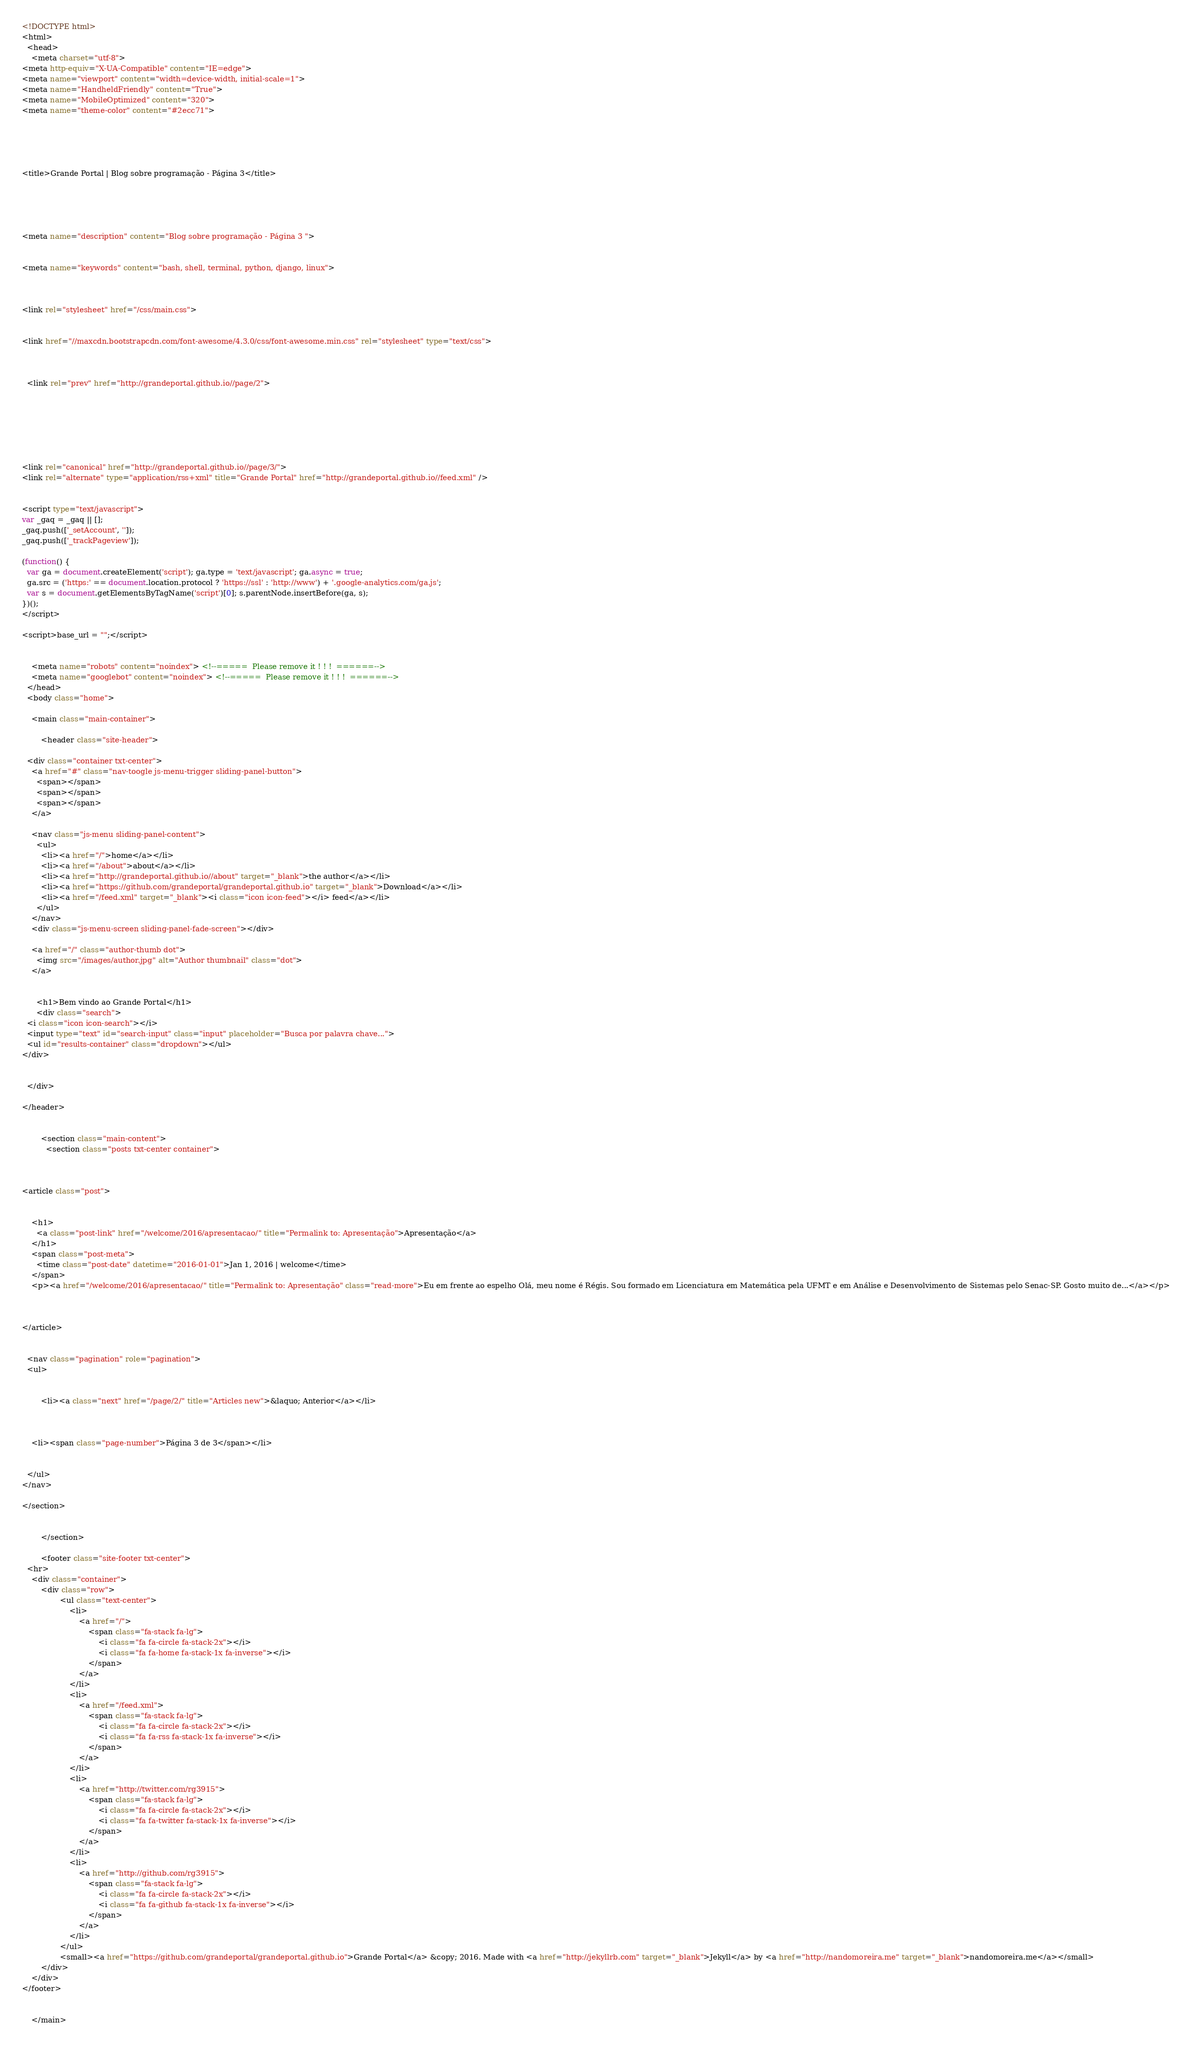Convert code to text. <code><loc_0><loc_0><loc_500><loc_500><_HTML_><!DOCTYPE html>
<html>
  <head>
    <meta charset="utf-8">
<meta http-equiv="X-UA-Compatible" content="IE=edge">
<meta name="viewport" content="width=device-width, initial-scale=1">
<meta name="HandheldFriendly" content="True">
<meta name="MobileOptimized" content="320">
<meta name="theme-color" content="#2ecc71">





<title>Grande Portal | Blog sobre programação - Página 3</title>





<meta name="description" content="Blog sobre programação - Página 3 ">


<meta name="keywords" content="bash, shell, terminal, python, django, linux">



<link rel="stylesheet" href="/css/main.css">


<link href="//maxcdn.bootstrapcdn.com/font-awesome/4.3.0/css/font-awesome.min.css" rel="stylesheet" type="text/css">



  <link rel="prev" href="http://grandeportal.github.io//page/2">







<link rel="canonical" href="http://grandeportal.github.io//page/3/">
<link rel="alternate" type="application/rss+xml" title="Grande Portal" href="http://grandeportal.github.io//feed.xml" />


<script type="text/javascript">
var _gaq = _gaq || [];
_gaq.push(['_setAccount', '']);
_gaq.push(['_trackPageview']);

(function() {
  var ga = document.createElement('script'); ga.type = 'text/javascript'; ga.async = true;
  ga.src = ('https:' == document.location.protocol ? 'https://ssl' : 'http://www') + '.google-analytics.com/ga.js';
  var s = document.getElementsByTagName('script')[0]; s.parentNode.insertBefore(ga, s);
})();
</script>

<script>base_url = "";</script>


    <meta name="robots" content="noindex"> <!--=====  Please remove it ! ! !  ======-->
    <meta name="googlebot" content="noindex"> <!--=====  Please remove it ! ! !  ======-->
  </head>
  <body class="home">

    <main class="main-container">

        <header class="site-header">

  <div class="container txt-center">
    <a href="#" class="nav-toogle js-menu-trigger sliding-panel-button">
      <span></span>
      <span></span>
      <span></span>
    </a>

    <nav class="js-menu sliding-panel-content">
      <ul>
        <li><a href="/">home</a></li>
        <li><a href="/about">about</a></li>
        <li><a href="http://grandeportal.github.io//about" target="_blank">the author</a></li>
        <li><a href="https://github.com/grandeportal/grandeportal.github.io" target="_blank">Download</a></li>
        <li><a href="/feed.xml" target="_blank"><i class="icon icon-feed"></i> feed</a></li>
      </ul>
    </nav>
    <div class="js-menu-screen sliding-panel-fade-screen"></div>

    <a href="/" class="author-thumb dot">
      <img src="/images/author.jpg" alt="Author thumbnail" class="dot">
    </a>

    
      <h1>Bem vindo ao Grande Portal</h1>
      <div class="search">
  <i class="icon icon-search"></i>
  <input type="text" id="search-input" class="input" placeholder="Busca por palavra chave...">
  <ul id="results-container" class="dropdown"></ul>
</div>
    

  </div>

</header>


        <section class="main-content">
          <section class="posts txt-center container">

  
    
<article class="post">

  
    <h1>
      <a class="post-link" href="/welcome/2016/apresentacao/" title="Permalink to: Apresentação">Apresentação</a>
    </h1>
    <span class="post-meta">
      <time class="post-date" datetime="2016-01-01">Jan 1, 2016 | welcome</time>
    </span>
    <p><a href="/welcome/2016/apresentacao/" title="Permalink to: Apresentação" class="read-more">Eu em frente ao espelho Olá, meu nome é Régis. Sou formado em Licenciatura em Matemática pela UFMT e em Análise e Desenvolvimento de Sistemas pelo Senac-SP. Gosto muito de...</a></p>
  


</article>
  

  <nav class="pagination" role="pagination">
  <ul>
    
      
        <li><a class="next" href="/page/2/" title="Articles new">&laquo; Anterior</a></li>
      
    

    <li><span class="page-number">Página 3 de 3</span></li>

    
  </ul>
</nav>

</section>


        </section>

        <footer class="site-footer txt-center">
  <hr>
    <div class="container">
        <div class="row">
                <ul class="text-center">
                    <li>
                        <a href="/">
                            <span class="fa-stack fa-lg">
                                <i class="fa fa-circle fa-stack-2x"></i>
                                <i class="fa fa-home fa-stack-1x fa-inverse"></i>
                            </span>
                        </a>
                    </li>
                    <li>
                        <a href="/feed.xml">
                            <span class="fa-stack fa-lg">
                                <i class="fa fa-circle fa-stack-2x"></i>
                                <i class="fa fa-rss fa-stack-1x fa-inverse"></i>
                            </span>
                        </a>
                    </li>
                    <li>
                        <a href="http://twitter.com/rg3915">
                            <span class="fa-stack fa-lg">
                                <i class="fa fa-circle fa-stack-2x"></i>
                                <i class="fa fa-twitter fa-stack-1x fa-inverse"></i>
                            </span>
                        </a>
                    </li>
                    <li>
                        <a href="http://github.com/rg3915">
                            <span class="fa-stack fa-lg">
                                <i class="fa fa-circle fa-stack-2x"></i>
                                <i class="fa fa-github fa-stack-1x fa-inverse"></i>
                            </span>
                        </a>
                    </li>
                </ul>
                <small><a href="https://github.com/grandeportal/grandeportal.github.io">Grande Portal</a> &copy; 2016. Made with <a href="http://jekyllrb.com" target="_blank">Jekyll</a> by <a href="http://nandomoreira.me" target="_blank">nandomoreira.me</a></small>
        </div>
    </div>
</footer>


    </main>
</code> 